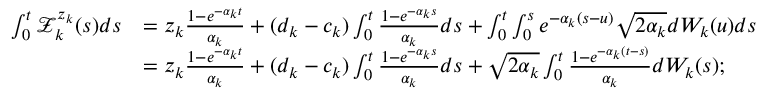<formula> <loc_0><loc_0><loc_500><loc_500>\begin{array} { r l } { \int _ { 0 } ^ { t } \mathcal { Z } _ { k } ^ { z _ { k } } ( s ) d s } & { = z _ { k } \frac { 1 - e ^ { - \alpha _ { k } t } } { \alpha _ { k } } + ( d _ { k } - c _ { k } ) \int _ { 0 } ^ { t } \frac { 1 - e ^ { - \alpha _ { k } s } } { \alpha _ { k } } d s + \int _ { 0 } ^ { t } \int _ { 0 } ^ { s } e ^ { - \alpha _ { k } ( s - u ) } \sqrt { 2 \alpha _ { k } } d W _ { k } ( u ) d s } \\ & { = z _ { k } \frac { 1 - e ^ { - \alpha _ { k } t } } { \alpha _ { k } } + ( d _ { k } - c _ { k } ) \int _ { 0 } ^ { t } \frac { 1 - e ^ { - \alpha _ { k } s } } { \alpha _ { k } } d s + \sqrt { 2 \alpha _ { k } } \int _ { 0 } ^ { t } \frac { 1 - e ^ { - \alpha _ { k } ( t - s ) } } { \alpha _ { k } } d W _ { k } ( s ) ; } \end{array}</formula> 